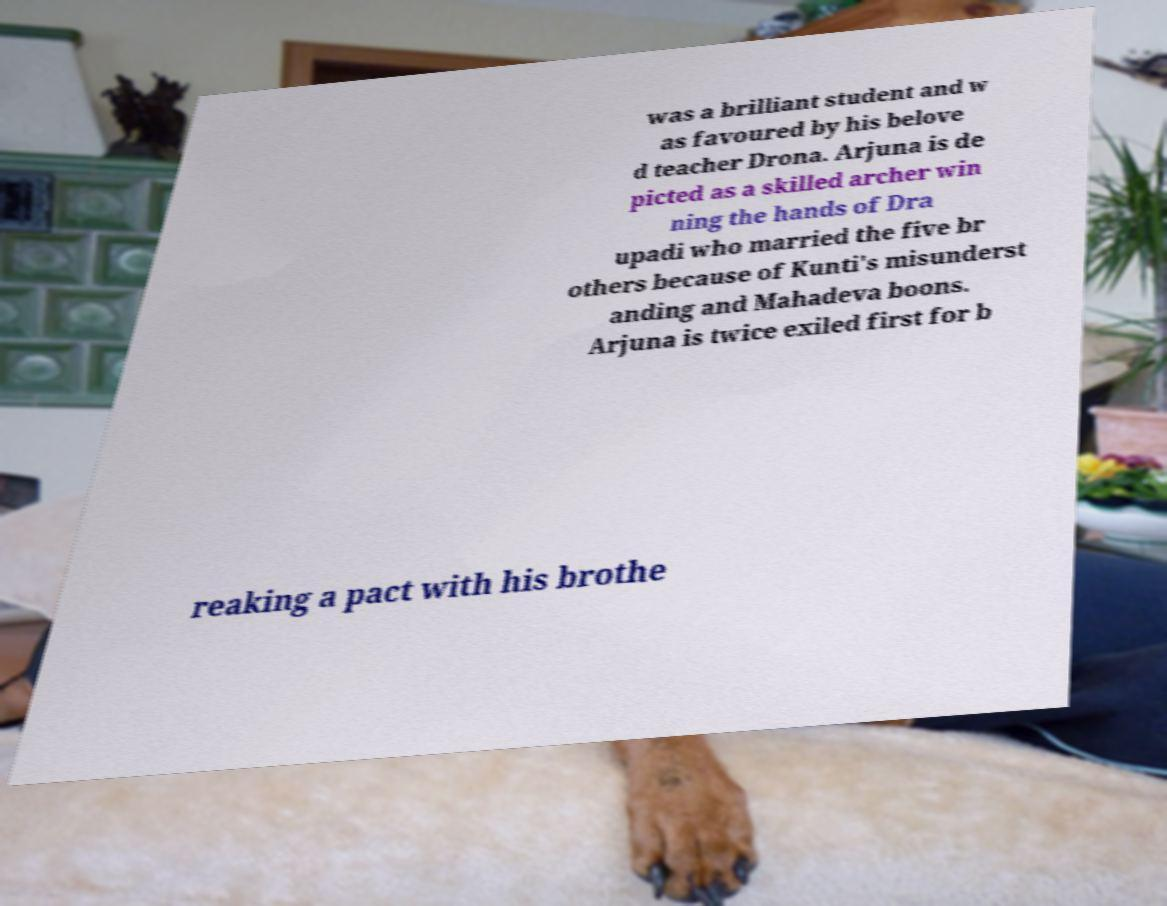I need the written content from this picture converted into text. Can you do that? was a brilliant student and w as favoured by his belove d teacher Drona. Arjuna is de picted as a skilled archer win ning the hands of Dra upadi who married the five br others because of Kunti's misunderst anding and Mahadeva boons. Arjuna is twice exiled first for b reaking a pact with his brothe 